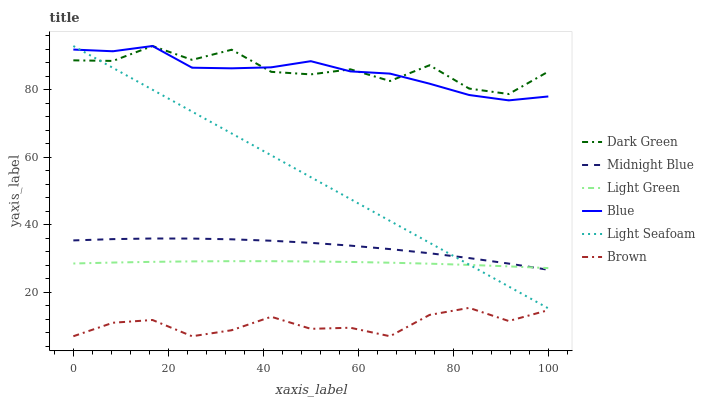Does Brown have the minimum area under the curve?
Answer yes or no. Yes. Does Dark Green have the maximum area under the curve?
Answer yes or no. Yes. Does Midnight Blue have the minimum area under the curve?
Answer yes or no. No. Does Midnight Blue have the maximum area under the curve?
Answer yes or no. No. Is Light Seafoam the smoothest?
Answer yes or no. Yes. Is Dark Green the roughest?
Answer yes or no. Yes. Is Brown the smoothest?
Answer yes or no. No. Is Brown the roughest?
Answer yes or no. No. Does Brown have the lowest value?
Answer yes or no. Yes. Does Midnight Blue have the lowest value?
Answer yes or no. No. Does Dark Green have the highest value?
Answer yes or no. Yes. Does Midnight Blue have the highest value?
Answer yes or no. No. Is Brown less than Dark Green?
Answer yes or no. Yes. Is Blue greater than Light Green?
Answer yes or no. Yes. Does Blue intersect Light Seafoam?
Answer yes or no. Yes. Is Blue less than Light Seafoam?
Answer yes or no. No. Is Blue greater than Light Seafoam?
Answer yes or no. No. Does Brown intersect Dark Green?
Answer yes or no. No. 